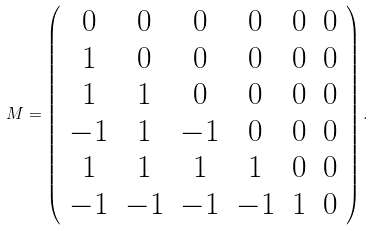<formula> <loc_0><loc_0><loc_500><loc_500>M = \left ( \begin{array} { c c c c c c } 0 & 0 & 0 & 0 & 0 & 0 \\ 1 & 0 & 0 & 0 & 0 & 0 \\ 1 & 1 & 0 & 0 & 0 & 0 \\ - 1 & 1 & - 1 & 0 & 0 & 0 \\ 1 & 1 & 1 & 1 & 0 & 0 \\ - 1 & - 1 & - 1 & - 1 & 1 & 0 \\ \end{array} \right ) .</formula> 